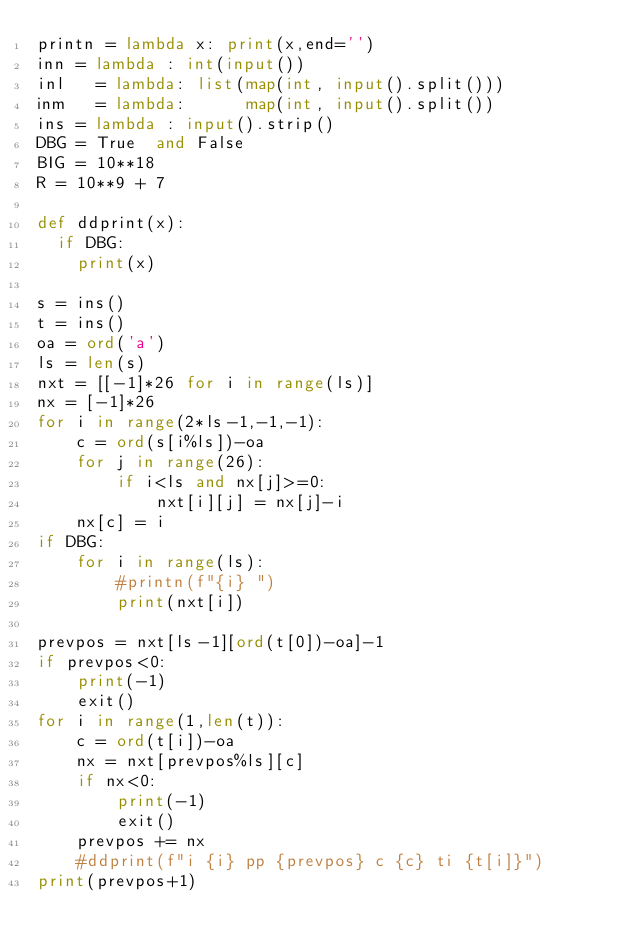Convert code to text. <code><loc_0><loc_0><loc_500><loc_500><_Python_>printn = lambda x: print(x,end='')
inn = lambda : int(input())
inl   = lambda: list(map(int, input().split()))
inm   = lambda:      map(int, input().split())
ins = lambda : input().strip()
DBG = True  and False
BIG = 10**18
R = 10**9 + 7

def ddprint(x):
  if DBG:
    print(x)

s = ins()
t = ins()
oa = ord('a')
ls = len(s)
nxt = [[-1]*26 for i in range(ls)]
nx = [-1]*26
for i in range(2*ls-1,-1,-1):
    c = ord(s[i%ls])-oa
    for j in range(26):
        if i<ls and nx[j]>=0:
            nxt[i][j] = nx[j]-i
    nx[c] = i
if DBG:
    for i in range(ls):
        #printn(f"{i} ")
        print(nxt[i])

prevpos = nxt[ls-1][ord(t[0])-oa]-1
if prevpos<0:
    print(-1)
    exit()
for i in range(1,len(t)):
    c = ord(t[i])-oa
    nx = nxt[prevpos%ls][c]
    if nx<0:
        print(-1)
        exit()
    prevpos += nx
    #ddprint(f"i {i} pp {prevpos} c {c} ti {t[i]}")
print(prevpos+1)
</code> 